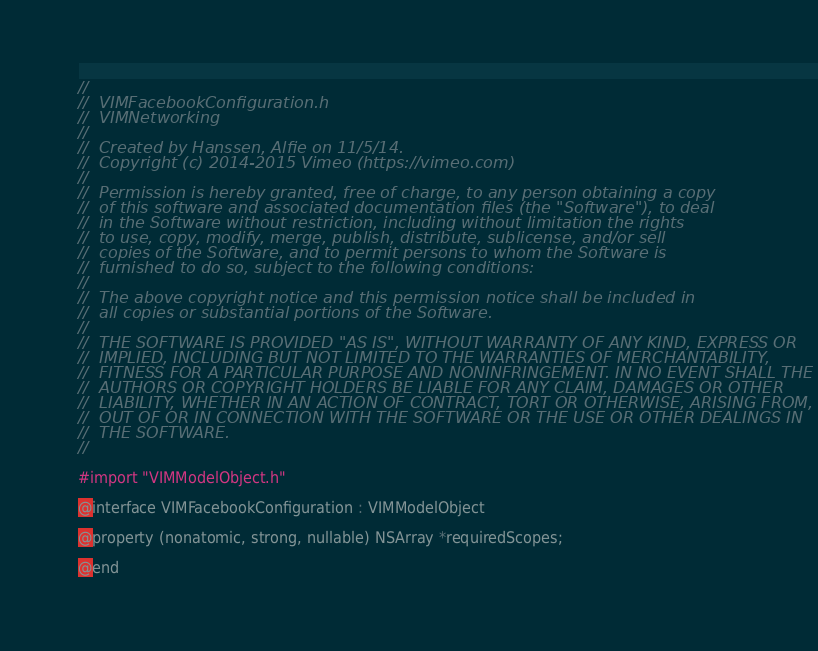<code> <loc_0><loc_0><loc_500><loc_500><_C_>//
//  VIMFacebookConfiguration.h
//  VIMNetworking
//
//  Created by Hanssen, Alfie on 11/5/14.
//  Copyright (c) 2014-2015 Vimeo (https://vimeo.com)
//
//  Permission is hereby granted, free of charge, to any person obtaining a copy
//  of this software and associated documentation files (the "Software"), to deal
//  in the Software without restriction, including without limitation the rights
//  to use, copy, modify, merge, publish, distribute, sublicense, and/or sell
//  copies of the Software, and to permit persons to whom the Software is
//  furnished to do so, subject to the following conditions:
//
//  The above copyright notice and this permission notice shall be included in
//  all copies or substantial portions of the Software.
//
//  THE SOFTWARE IS PROVIDED "AS IS", WITHOUT WARRANTY OF ANY KIND, EXPRESS OR
//  IMPLIED, INCLUDING BUT NOT LIMITED TO THE WARRANTIES OF MERCHANTABILITY,
//  FITNESS FOR A PARTICULAR PURPOSE AND NONINFRINGEMENT. IN NO EVENT SHALL THE
//  AUTHORS OR COPYRIGHT HOLDERS BE LIABLE FOR ANY CLAIM, DAMAGES OR OTHER
//  LIABILITY, WHETHER IN AN ACTION OF CONTRACT, TORT OR OTHERWISE, ARISING FROM,
//  OUT OF OR IN CONNECTION WITH THE SOFTWARE OR THE USE OR OTHER DEALINGS IN
//  THE SOFTWARE.
//

#import "VIMModelObject.h"

@interface VIMFacebookConfiguration : VIMModelObject

@property (nonatomic, strong, nullable) NSArray *requiredScopes;

@end
</code> 